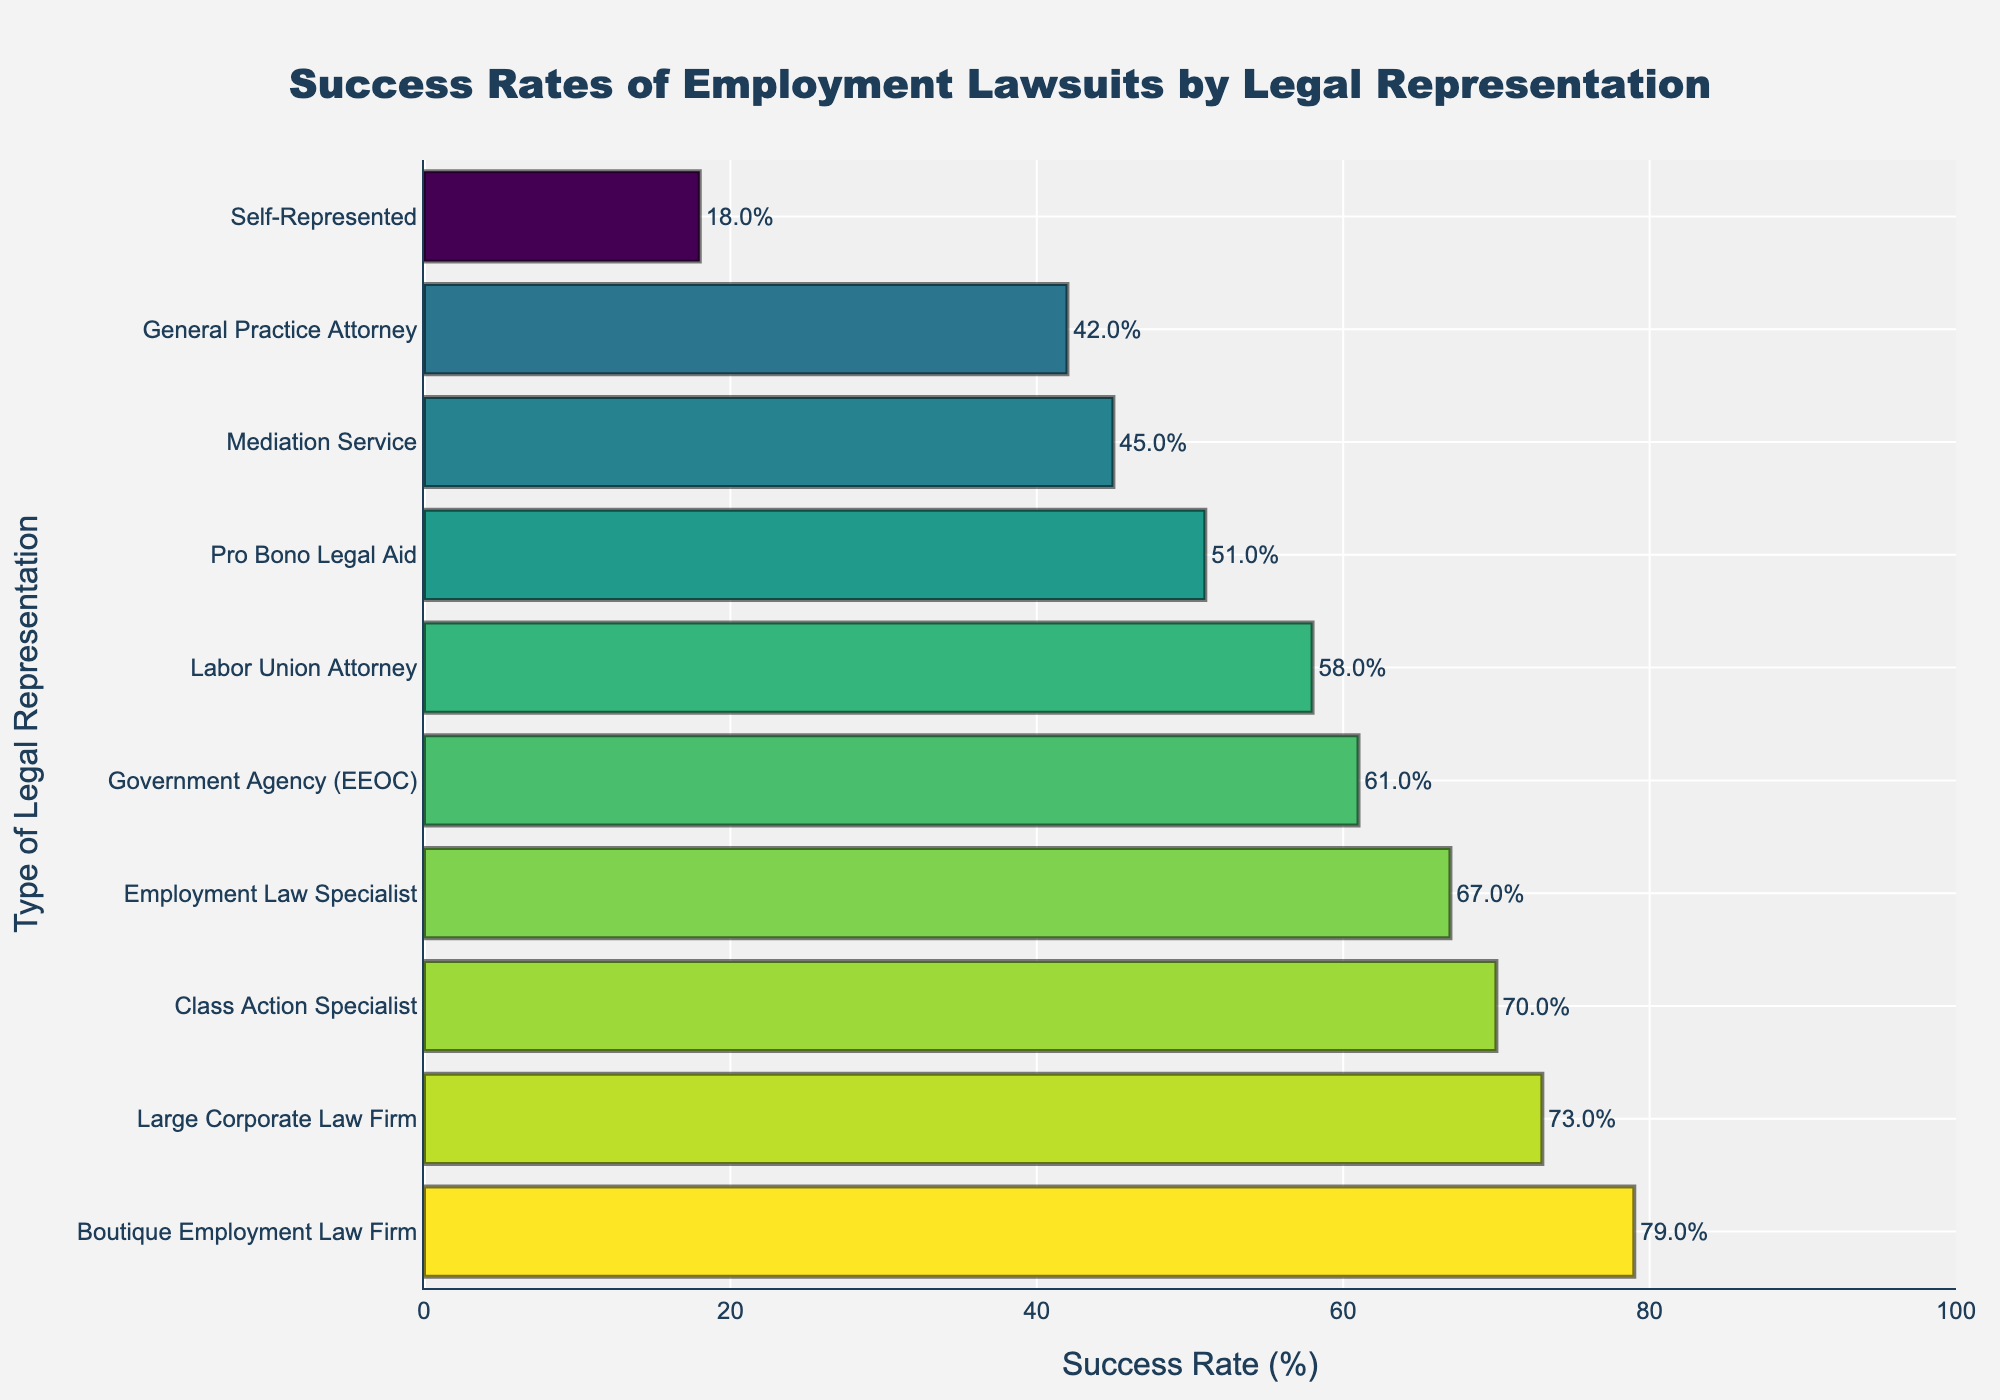What type of legal representation has the highest success rate? The highest bar represents the type of legal representation with the highest success rate, which is the "Boutique Employment Law Firm" at 79%.
Answer: Boutique Employment Law Firm What is the success rate for self-represented cases? Check the bar labeled "Self-Represented" for its success rate, which is 18%.
Answer: 18% How does the success rate of an Employment Law Specialist compare with a General Practice Attorney? The bar for Employment Law Specialist is higher than that for General Practice Attorney, indicating Employment Law Specialist has a higher success rate (67%) compared to General Practice Attorney (42%).
Answer: Employment Law Specialist has a higher success rate by 25 percentage points What is the average success rate of all types of legal representation in the chart? Add all the success rates and divide by the number of categories. (18 + 42 + 67 + 58 + 51 + 73 + 79 + 61 + 45 + 70) / 10 = 56.4%.
Answer: 56.4% If you combined the success rates of Pro Bono Legal Aid and Government Agency (EEOC), what would be the average success rate? Add the success rates for Pro Bono Legal Aid (51%) and Government Agency (EEOC) (61%), then divide by 2. (51 + 61) / 2 = 56%.
Answer: 56% Which legal representation type has the closest success rate to 45%? The bar labeled "Mediation Service" has a success rate of 45%, which is the closest to 45% in the chart.
Answer: Mediation Service Is the success rate of Large Corporate Law Firm greater than 70%? Check the bar labeled "Large Corporate Law Firm", which shows a success rate of 73%, which is greater than 70%.
Answer: Yes What is the difference in success rates between Labor Union Attorney and Class Action Specialist? Subtract the success rate of Labor Union Attorney (58%) from Class Action Specialist (70%). 70 - 58 = 12%.
Answer: 12% Are there any legal representation types with a success rate below 20%? The bar labeled "Self-Represented" is the only one with a success rate below 20%, which is 18%.
Answer: Yes What is the median success rate of the legal representation types shown in the chart? Arrange the success rates in ascending order: 18, 42, 45, 51, 58, 61, 67, 70, 73, 79. With 10 values, the median is the average of the 5th and 6th values: (58 + 61) / 2 = 59.5%.
Answer: 59.5% 